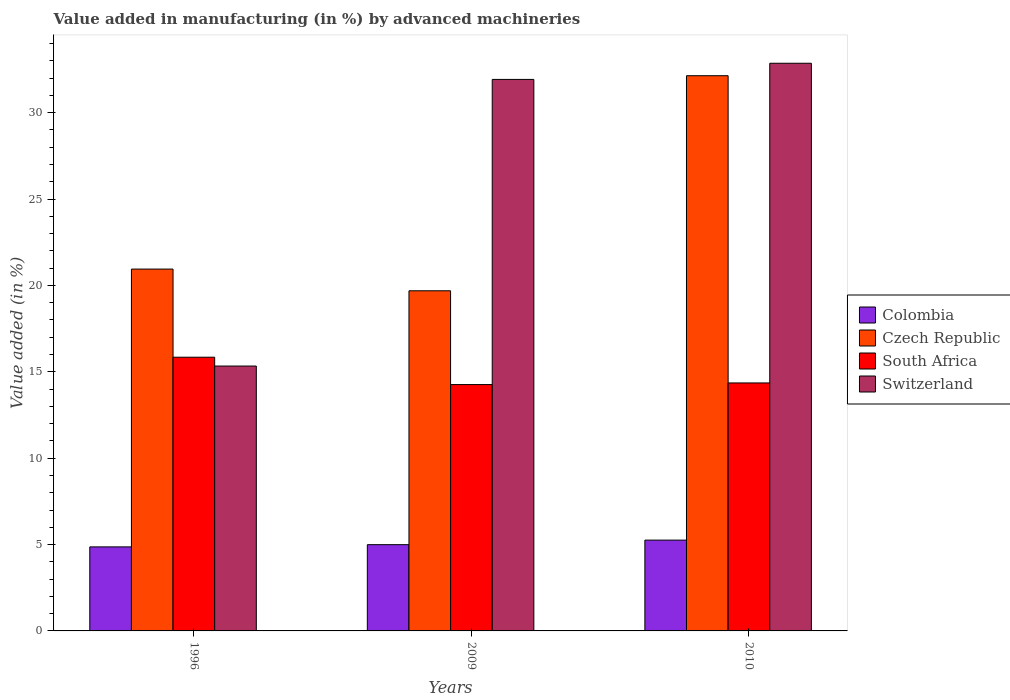How many different coloured bars are there?
Keep it short and to the point. 4. How many groups of bars are there?
Your answer should be compact. 3. Are the number of bars per tick equal to the number of legend labels?
Provide a short and direct response. Yes. What is the percentage of value added in manufacturing by advanced machineries in Czech Republic in 1996?
Provide a succinct answer. 20.95. Across all years, what is the maximum percentage of value added in manufacturing by advanced machineries in South Africa?
Give a very brief answer. 15.85. Across all years, what is the minimum percentage of value added in manufacturing by advanced machineries in Switzerland?
Your response must be concise. 15.33. What is the total percentage of value added in manufacturing by advanced machineries in Switzerland in the graph?
Ensure brevity in your answer.  80.12. What is the difference between the percentage of value added in manufacturing by advanced machineries in Colombia in 1996 and that in 2010?
Your answer should be very brief. -0.39. What is the difference between the percentage of value added in manufacturing by advanced machineries in Colombia in 2009 and the percentage of value added in manufacturing by advanced machineries in South Africa in 1996?
Provide a short and direct response. -10.85. What is the average percentage of value added in manufacturing by advanced machineries in South Africa per year?
Provide a short and direct response. 14.82. In the year 2009, what is the difference between the percentage of value added in manufacturing by advanced machineries in South Africa and percentage of value added in manufacturing by advanced machineries in Colombia?
Your response must be concise. 9.27. What is the ratio of the percentage of value added in manufacturing by advanced machineries in Switzerland in 1996 to that in 2009?
Offer a terse response. 0.48. Is the percentage of value added in manufacturing by advanced machineries in Colombia in 1996 less than that in 2009?
Provide a succinct answer. Yes. What is the difference between the highest and the second highest percentage of value added in manufacturing by advanced machineries in Czech Republic?
Your answer should be very brief. 11.19. What is the difference between the highest and the lowest percentage of value added in manufacturing by advanced machineries in South Africa?
Keep it short and to the point. 1.58. What does the 2nd bar from the left in 1996 represents?
Give a very brief answer. Czech Republic. What does the 4th bar from the right in 2009 represents?
Give a very brief answer. Colombia. Is it the case that in every year, the sum of the percentage of value added in manufacturing by advanced machineries in Switzerland and percentage of value added in manufacturing by advanced machineries in South Africa is greater than the percentage of value added in manufacturing by advanced machineries in Czech Republic?
Keep it short and to the point. Yes. How many bars are there?
Provide a short and direct response. 12. Are all the bars in the graph horizontal?
Offer a terse response. No. Does the graph contain any zero values?
Keep it short and to the point. No. Does the graph contain grids?
Your answer should be compact. No. Where does the legend appear in the graph?
Your answer should be compact. Center right. What is the title of the graph?
Offer a very short reply. Value added in manufacturing (in %) by advanced machineries. What is the label or title of the X-axis?
Provide a succinct answer. Years. What is the label or title of the Y-axis?
Your response must be concise. Value added (in %). What is the Value added (in %) in Colombia in 1996?
Your answer should be very brief. 4.86. What is the Value added (in %) of Czech Republic in 1996?
Keep it short and to the point. 20.95. What is the Value added (in %) in South Africa in 1996?
Give a very brief answer. 15.85. What is the Value added (in %) in Switzerland in 1996?
Provide a succinct answer. 15.33. What is the Value added (in %) of Colombia in 2009?
Offer a very short reply. 4.99. What is the Value added (in %) of Czech Republic in 2009?
Your answer should be compact. 19.69. What is the Value added (in %) in South Africa in 2009?
Offer a terse response. 14.26. What is the Value added (in %) in Switzerland in 2009?
Offer a very short reply. 31.93. What is the Value added (in %) of Colombia in 2010?
Ensure brevity in your answer.  5.26. What is the Value added (in %) in Czech Republic in 2010?
Provide a succinct answer. 32.14. What is the Value added (in %) in South Africa in 2010?
Your response must be concise. 14.36. What is the Value added (in %) of Switzerland in 2010?
Give a very brief answer. 32.86. Across all years, what is the maximum Value added (in %) of Colombia?
Make the answer very short. 5.26. Across all years, what is the maximum Value added (in %) in Czech Republic?
Provide a succinct answer. 32.14. Across all years, what is the maximum Value added (in %) of South Africa?
Ensure brevity in your answer.  15.85. Across all years, what is the maximum Value added (in %) in Switzerland?
Keep it short and to the point. 32.86. Across all years, what is the minimum Value added (in %) of Colombia?
Your answer should be very brief. 4.86. Across all years, what is the minimum Value added (in %) of Czech Republic?
Make the answer very short. 19.69. Across all years, what is the minimum Value added (in %) of South Africa?
Ensure brevity in your answer.  14.26. Across all years, what is the minimum Value added (in %) of Switzerland?
Provide a succinct answer. 15.33. What is the total Value added (in %) in Colombia in the graph?
Offer a very short reply. 15.12. What is the total Value added (in %) of Czech Republic in the graph?
Your response must be concise. 72.78. What is the total Value added (in %) of South Africa in the graph?
Provide a succinct answer. 44.46. What is the total Value added (in %) of Switzerland in the graph?
Keep it short and to the point. 80.12. What is the difference between the Value added (in %) of Colombia in 1996 and that in 2009?
Make the answer very short. -0.13. What is the difference between the Value added (in %) of Czech Republic in 1996 and that in 2009?
Ensure brevity in your answer.  1.26. What is the difference between the Value added (in %) in South Africa in 1996 and that in 2009?
Your answer should be very brief. 1.58. What is the difference between the Value added (in %) of Switzerland in 1996 and that in 2009?
Offer a terse response. -16.59. What is the difference between the Value added (in %) of Colombia in 1996 and that in 2010?
Offer a very short reply. -0.39. What is the difference between the Value added (in %) in Czech Republic in 1996 and that in 2010?
Provide a short and direct response. -11.19. What is the difference between the Value added (in %) in South Africa in 1996 and that in 2010?
Your answer should be very brief. 1.49. What is the difference between the Value added (in %) of Switzerland in 1996 and that in 2010?
Provide a succinct answer. -17.53. What is the difference between the Value added (in %) in Colombia in 2009 and that in 2010?
Provide a short and direct response. -0.26. What is the difference between the Value added (in %) of Czech Republic in 2009 and that in 2010?
Provide a succinct answer. -12.45. What is the difference between the Value added (in %) in South Africa in 2009 and that in 2010?
Keep it short and to the point. -0.09. What is the difference between the Value added (in %) of Switzerland in 2009 and that in 2010?
Your answer should be compact. -0.94. What is the difference between the Value added (in %) of Colombia in 1996 and the Value added (in %) of Czech Republic in 2009?
Ensure brevity in your answer.  -14.83. What is the difference between the Value added (in %) in Colombia in 1996 and the Value added (in %) in South Africa in 2009?
Offer a very short reply. -9.4. What is the difference between the Value added (in %) in Colombia in 1996 and the Value added (in %) in Switzerland in 2009?
Your answer should be compact. -27.06. What is the difference between the Value added (in %) in Czech Republic in 1996 and the Value added (in %) in South Africa in 2009?
Your response must be concise. 6.69. What is the difference between the Value added (in %) in Czech Republic in 1996 and the Value added (in %) in Switzerland in 2009?
Provide a short and direct response. -10.98. What is the difference between the Value added (in %) in South Africa in 1996 and the Value added (in %) in Switzerland in 2009?
Provide a short and direct response. -16.08. What is the difference between the Value added (in %) in Colombia in 1996 and the Value added (in %) in Czech Republic in 2010?
Make the answer very short. -27.28. What is the difference between the Value added (in %) in Colombia in 1996 and the Value added (in %) in South Africa in 2010?
Your response must be concise. -9.49. What is the difference between the Value added (in %) of Colombia in 1996 and the Value added (in %) of Switzerland in 2010?
Your response must be concise. -28. What is the difference between the Value added (in %) of Czech Republic in 1996 and the Value added (in %) of South Africa in 2010?
Ensure brevity in your answer.  6.59. What is the difference between the Value added (in %) of Czech Republic in 1996 and the Value added (in %) of Switzerland in 2010?
Offer a very short reply. -11.92. What is the difference between the Value added (in %) of South Africa in 1996 and the Value added (in %) of Switzerland in 2010?
Ensure brevity in your answer.  -17.02. What is the difference between the Value added (in %) of Colombia in 2009 and the Value added (in %) of Czech Republic in 2010?
Provide a short and direct response. -27.15. What is the difference between the Value added (in %) in Colombia in 2009 and the Value added (in %) in South Africa in 2010?
Your response must be concise. -9.36. What is the difference between the Value added (in %) of Colombia in 2009 and the Value added (in %) of Switzerland in 2010?
Your answer should be compact. -27.87. What is the difference between the Value added (in %) in Czech Republic in 2009 and the Value added (in %) in South Africa in 2010?
Your answer should be very brief. 5.33. What is the difference between the Value added (in %) of Czech Republic in 2009 and the Value added (in %) of Switzerland in 2010?
Provide a short and direct response. -13.17. What is the difference between the Value added (in %) of South Africa in 2009 and the Value added (in %) of Switzerland in 2010?
Make the answer very short. -18.6. What is the average Value added (in %) in Colombia per year?
Offer a very short reply. 5.04. What is the average Value added (in %) of Czech Republic per year?
Provide a short and direct response. 24.26. What is the average Value added (in %) in South Africa per year?
Offer a terse response. 14.82. What is the average Value added (in %) of Switzerland per year?
Provide a succinct answer. 26.71. In the year 1996, what is the difference between the Value added (in %) in Colombia and Value added (in %) in Czech Republic?
Make the answer very short. -16.08. In the year 1996, what is the difference between the Value added (in %) in Colombia and Value added (in %) in South Africa?
Offer a very short reply. -10.98. In the year 1996, what is the difference between the Value added (in %) in Colombia and Value added (in %) in Switzerland?
Ensure brevity in your answer.  -10.47. In the year 1996, what is the difference between the Value added (in %) in Czech Republic and Value added (in %) in South Africa?
Keep it short and to the point. 5.1. In the year 1996, what is the difference between the Value added (in %) in Czech Republic and Value added (in %) in Switzerland?
Your answer should be very brief. 5.61. In the year 1996, what is the difference between the Value added (in %) of South Africa and Value added (in %) of Switzerland?
Give a very brief answer. 0.51. In the year 2009, what is the difference between the Value added (in %) in Colombia and Value added (in %) in Czech Republic?
Your answer should be compact. -14.7. In the year 2009, what is the difference between the Value added (in %) in Colombia and Value added (in %) in South Africa?
Ensure brevity in your answer.  -9.27. In the year 2009, what is the difference between the Value added (in %) of Colombia and Value added (in %) of Switzerland?
Provide a short and direct response. -26.93. In the year 2009, what is the difference between the Value added (in %) of Czech Republic and Value added (in %) of South Africa?
Your answer should be compact. 5.43. In the year 2009, what is the difference between the Value added (in %) of Czech Republic and Value added (in %) of Switzerland?
Your response must be concise. -12.24. In the year 2009, what is the difference between the Value added (in %) in South Africa and Value added (in %) in Switzerland?
Give a very brief answer. -17.67. In the year 2010, what is the difference between the Value added (in %) of Colombia and Value added (in %) of Czech Republic?
Provide a succinct answer. -26.88. In the year 2010, what is the difference between the Value added (in %) in Colombia and Value added (in %) in South Africa?
Give a very brief answer. -9.1. In the year 2010, what is the difference between the Value added (in %) in Colombia and Value added (in %) in Switzerland?
Your answer should be very brief. -27.61. In the year 2010, what is the difference between the Value added (in %) in Czech Republic and Value added (in %) in South Africa?
Your answer should be very brief. 17.79. In the year 2010, what is the difference between the Value added (in %) of Czech Republic and Value added (in %) of Switzerland?
Offer a very short reply. -0.72. In the year 2010, what is the difference between the Value added (in %) of South Africa and Value added (in %) of Switzerland?
Your response must be concise. -18.51. What is the ratio of the Value added (in %) in Colombia in 1996 to that in 2009?
Your answer should be very brief. 0.97. What is the ratio of the Value added (in %) of Czech Republic in 1996 to that in 2009?
Offer a very short reply. 1.06. What is the ratio of the Value added (in %) in South Africa in 1996 to that in 2009?
Your answer should be compact. 1.11. What is the ratio of the Value added (in %) of Switzerland in 1996 to that in 2009?
Provide a short and direct response. 0.48. What is the ratio of the Value added (in %) in Colombia in 1996 to that in 2010?
Provide a short and direct response. 0.93. What is the ratio of the Value added (in %) in Czech Republic in 1996 to that in 2010?
Your response must be concise. 0.65. What is the ratio of the Value added (in %) in South Africa in 1996 to that in 2010?
Offer a terse response. 1.1. What is the ratio of the Value added (in %) in Switzerland in 1996 to that in 2010?
Provide a short and direct response. 0.47. What is the ratio of the Value added (in %) of Colombia in 2009 to that in 2010?
Make the answer very short. 0.95. What is the ratio of the Value added (in %) in Czech Republic in 2009 to that in 2010?
Make the answer very short. 0.61. What is the ratio of the Value added (in %) of South Africa in 2009 to that in 2010?
Give a very brief answer. 0.99. What is the ratio of the Value added (in %) in Switzerland in 2009 to that in 2010?
Your answer should be very brief. 0.97. What is the difference between the highest and the second highest Value added (in %) in Colombia?
Ensure brevity in your answer.  0.26. What is the difference between the highest and the second highest Value added (in %) of Czech Republic?
Ensure brevity in your answer.  11.19. What is the difference between the highest and the second highest Value added (in %) in South Africa?
Your response must be concise. 1.49. What is the difference between the highest and the second highest Value added (in %) of Switzerland?
Your answer should be compact. 0.94. What is the difference between the highest and the lowest Value added (in %) of Colombia?
Keep it short and to the point. 0.39. What is the difference between the highest and the lowest Value added (in %) of Czech Republic?
Offer a terse response. 12.45. What is the difference between the highest and the lowest Value added (in %) of South Africa?
Provide a succinct answer. 1.58. What is the difference between the highest and the lowest Value added (in %) of Switzerland?
Your response must be concise. 17.53. 